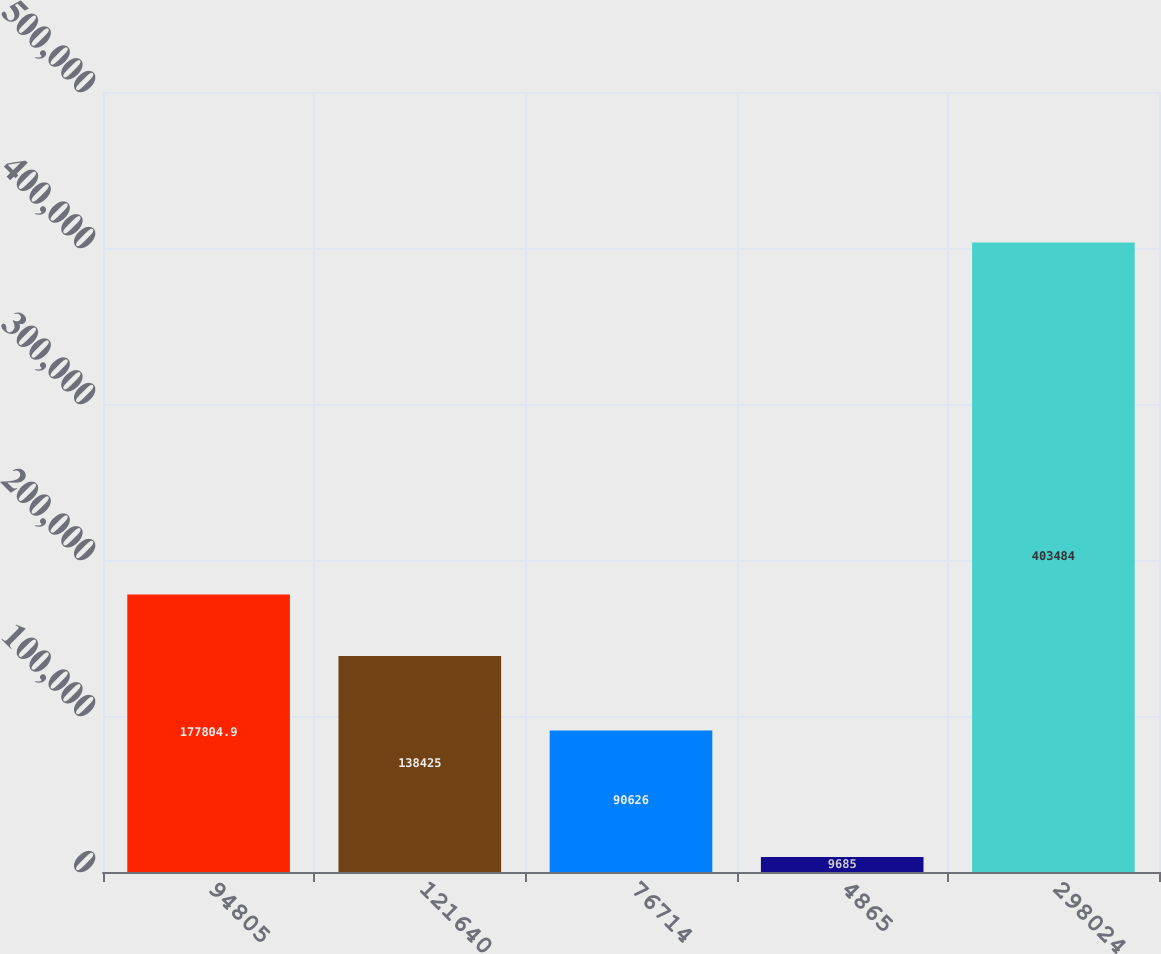Convert chart. <chart><loc_0><loc_0><loc_500><loc_500><bar_chart><fcel>94805<fcel>121640<fcel>76714<fcel>4865<fcel>298024<nl><fcel>177805<fcel>138425<fcel>90626<fcel>9685<fcel>403484<nl></chart> 